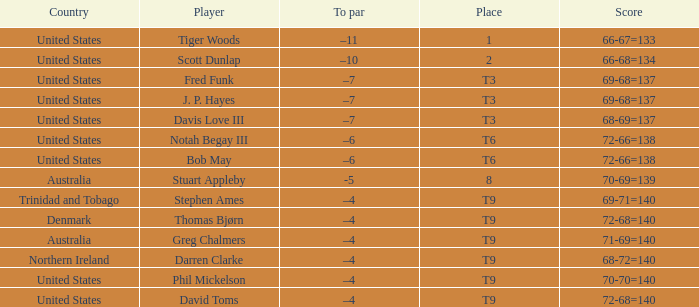What is the To par value that goes with a Score of 70-69=139? -5.0. 